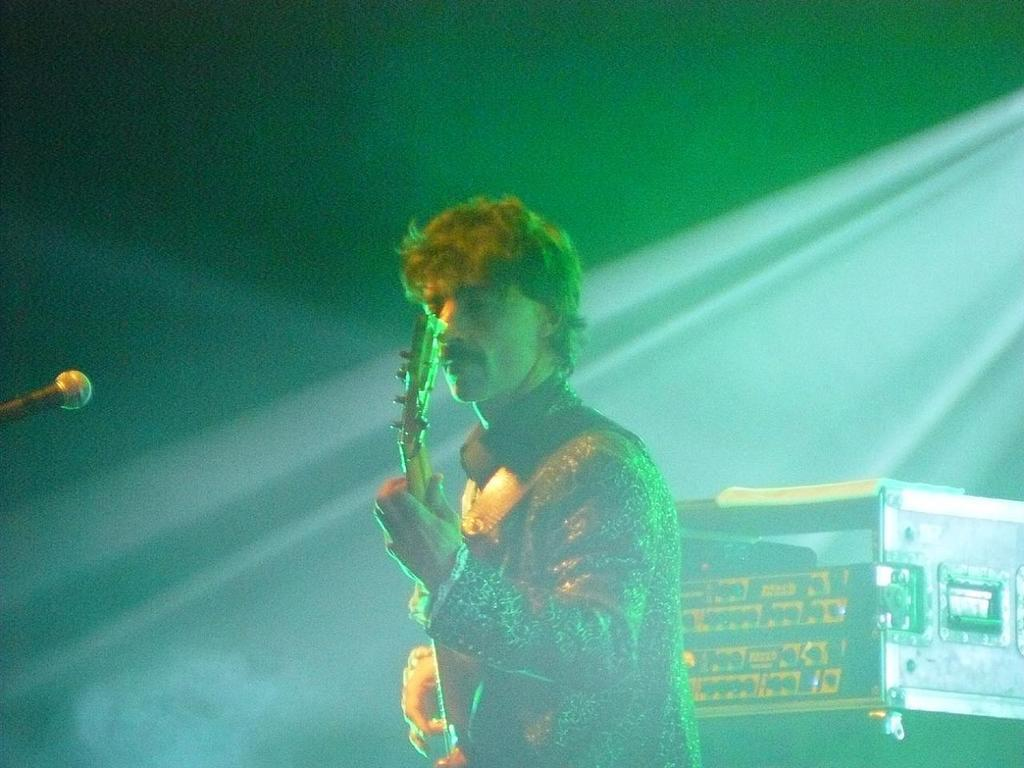What is the man in the image doing? The man is standing in the image and holding a guitar in his hand. What object is present on the left side of the image? There is a microphone on the left side of the image. What can be seen behind the man in the image? There is a box visible behind the man. What type of business is being conducted in the image? There is no indication of a business being conducted in the image; it primarily features a man holding a guitar. What treatment is being administered to the man in the image? There is no treatment being administered to the man in the image; he is simply holding a guitar. 